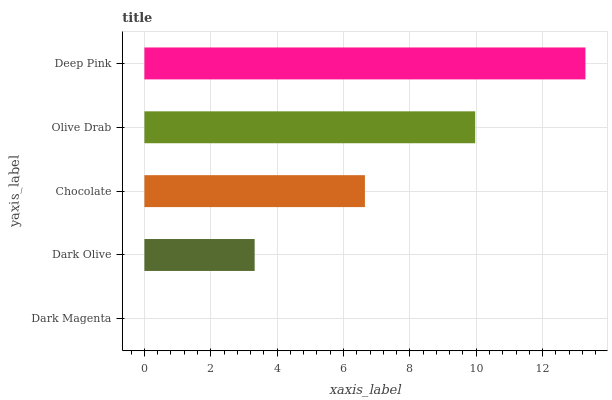Is Dark Magenta the minimum?
Answer yes or no. Yes. Is Deep Pink the maximum?
Answer yes or no. Yes. Is Dark Olive the minimum?
Answer yes or no. No. Is Dark Olive the maximum?
Answer yes or no. No. Is Dark Olive greater than Dark Magenta?
Answer yes or no. Yes. Is Dark Magenta less than Dark Olive?
Answer yes or no. Yes. Is Dark Magenta greater than Dark Olive?
Answer yes or no. No. Is Dark Olive less than Dark Magenta?
Answer yes or no. No. Is Chocolate the high median?
Answer yes or no. Yes. Is Chocolate the low median?
Answer yes or no. Yes. Is Dark Magenta the high median?
Answer yes or no. No. Is Olive Drab the low median?
Answer yes or no. No. 